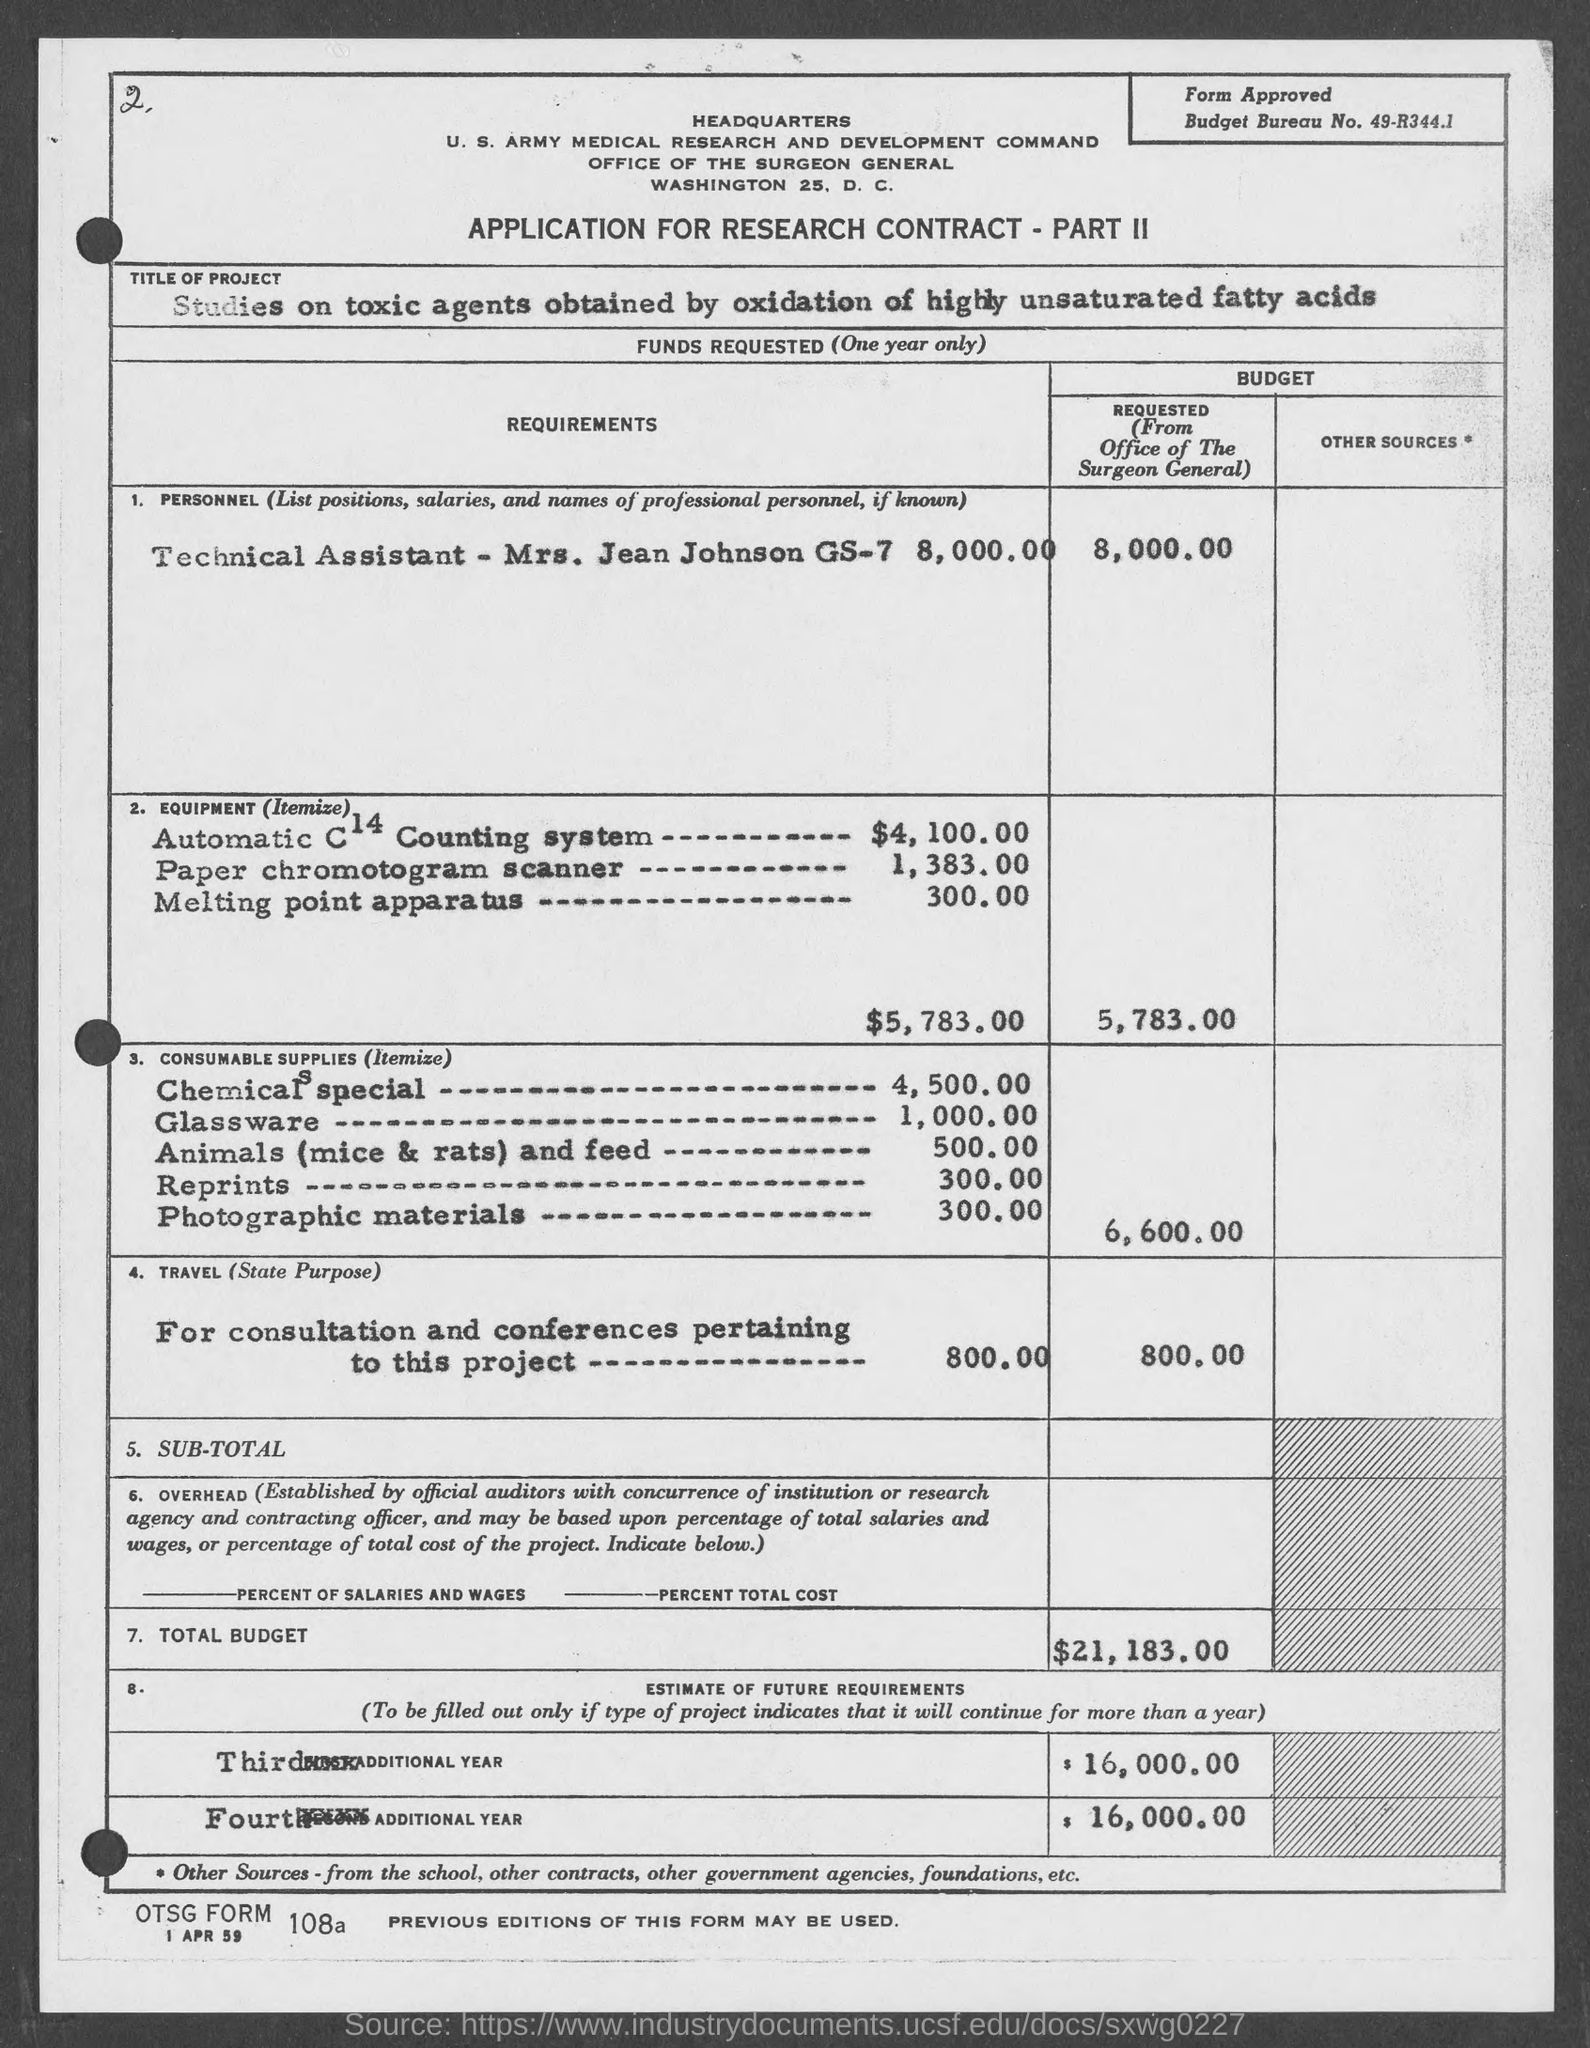What is the title of the project?
Your answer should be very brief. Studies on toxic agents obtained by oxidation of highly unsaturated fatty acids. What is the name of the technical assistant?
Your answer should be compact. Mrs. Jean Johnson. What is the budget requested for equipment?
Offer a terse response. 5,783.00. What is the budget requested for consumable supplies?
Provide a succinct answer. 6,600.00. What is the total budget requested?
Make the answer very short. $21,183.00. What is the estimate of future requirements requested for third and fourth additional year?
Make the answer very short. $ 16,000.00. 